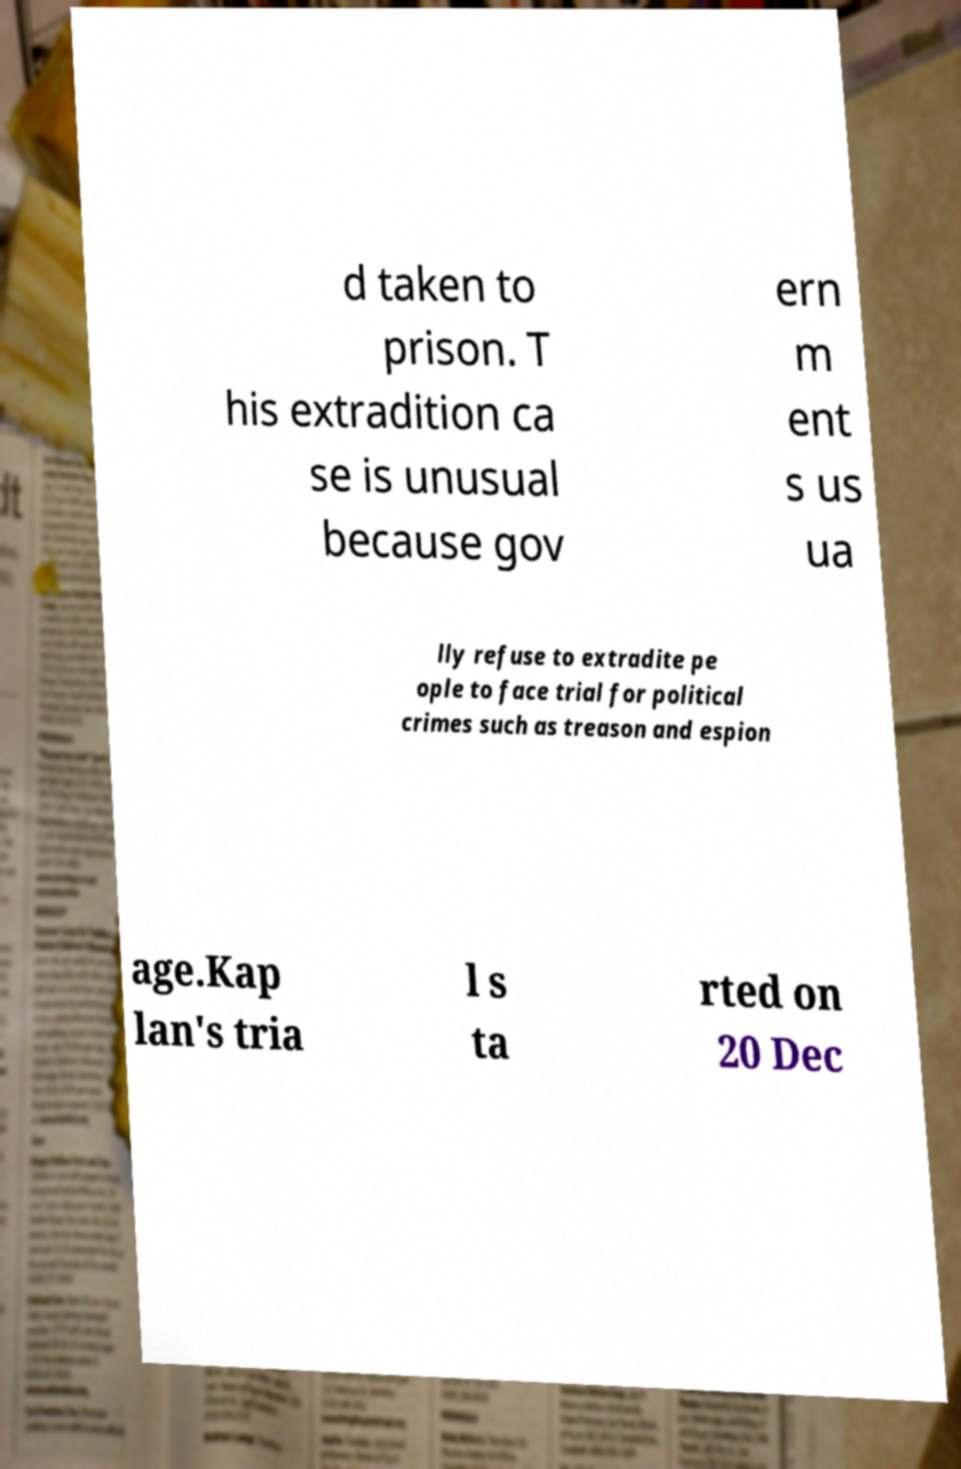For documentation purposes, I need the text within this image transcribed. Could you provide that? d taken to prison. T his extradition ca se is unusual because gov ern m ent s us ua lly refuse to extradite pe ople to face trial for political crimes such as treason and espion age.Kap lan's tria l s ta rted on 20 Dec 